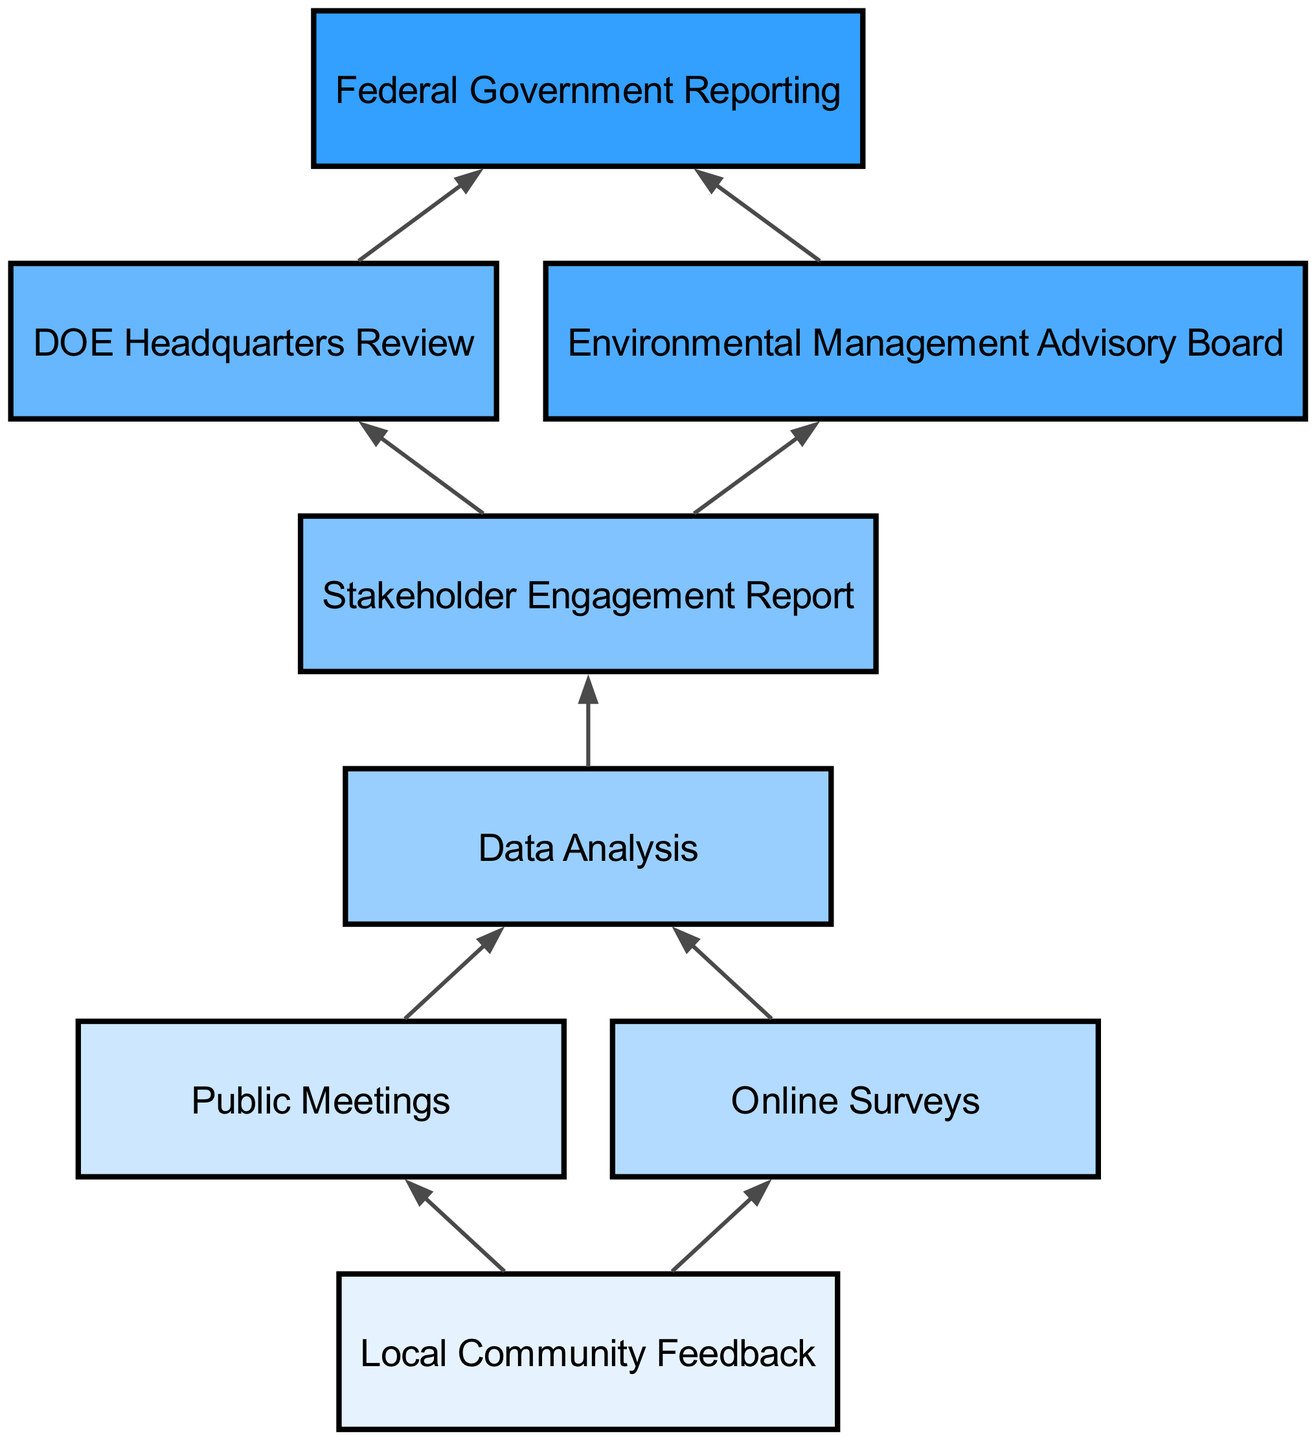What is the first step in OREM's stakeholder engagement strategy? The first step in the flow is "Local Community Feedback," which is indicated at the top of the diagram. This represents the initial stage of engagement before proceeding to other steps.
Answer: Local Community Feedback How many connections lead from the "Local Community Feedback" node? "Local Community Feedback" connects to two nodes: "Public Meetings" and "Online Surveys," as seen in the diagram. Each connection signifies a method of gathering feedback.
Answer: 2 What node follows "Data Analysis"? The node that follows "Data Analysis" is the "Stakeholder Engagement Report." The flow goes from data analysis directly to reporting, indicating it's a subsequent step.
Answer: Stakeholder Engagement Report Which two processes follow the "Stakeholder Engagement Report"? The two processes following the "Stakeholder Engagement Report" are "DOE Headquarters Review" and "Environmental Management Advisory Board," shown clearly as branches stemming from the reporting stage.
Answer: DOE Headquarters Review, Environmental Management Advisory Board What is the final outcome in the stakeholder engagement strategy? The final outcome in the flow is "Federal Government Reporting," marking the conclusion of the engagement process and subsequent reporting obligations.
Answer: Federal Government Reporting How does "Public Meetings" contribute to the flow of the diagram? "Public Meetings" is connected directly to "Data Analysis," meaning that feedback gathered at public meetings plays a crucial role in compiling data for further analysis, showcasing its importance in the stakeholder engagement strategy.
Answer: Directly contributes data What step immediately precedes "Federal Government Reporting"? The steps immediately preceding "Federal Government Reporting" are both "DOE Headquarters Review" and "Environmental Management Advisory Board," indicating that these reviews are necessary before final reporting can occur.
Answer: DOE Headquarters Review, Environmental Management Advisory Board Which engagement method connects to "Data Analysis"? Both "Public Meetings" and "Online Surveys" connect to "Data Analysis," indicating that data collected from these two methods is synthesized for analysis to inform further actions in the engagement strategy.
Answer: Public Meetings, Online Surveys How many nodes directly contribute feedback to "Data Analysis"? There are two nodes that directly contribute feedback to "Data Analysis." These are "Public Meetings" and "Online Surveys," which gather community input that is analyzed further in the strategy.
Answer: 2 